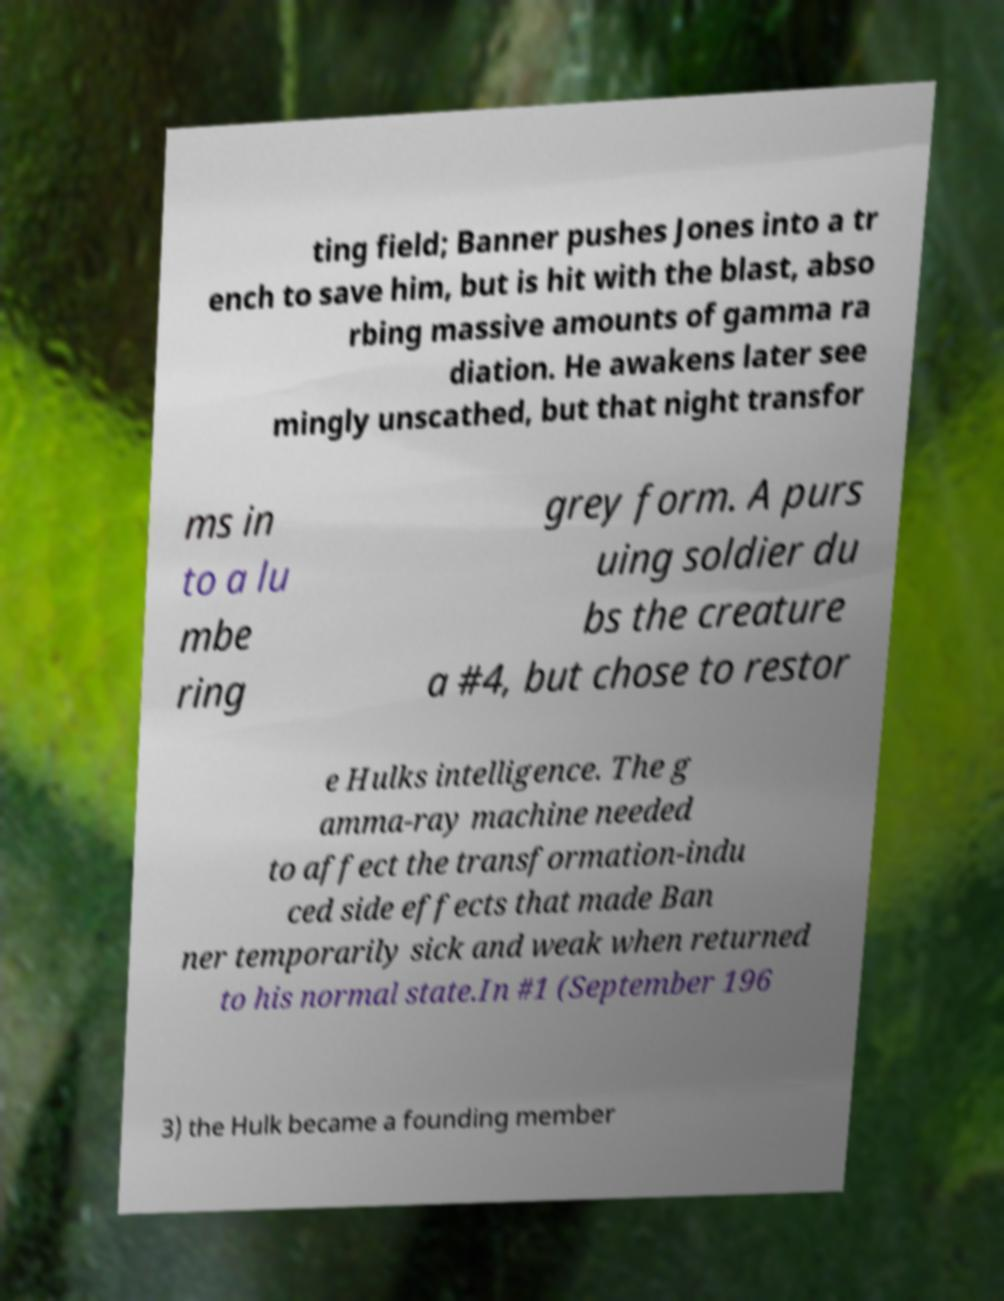Please read and relay the text visible in this image. What does it say? ting field; Banner pushes Jones into a tr ench to save him, but is hit with the blast, abso rbing massive amounts of gamma ra diation. He awakens later see mingly unscathed, but that night transfor ms in to a lu mbe ring grey form. A purs uing soldier du bs the creature a #4, but chose to restor e Hulks intelligence. The g amma-ray machine needed to affect the transformation-indu ced side effects that made Ban ner temporarily sick and weak when returned to his normal state.In #1 (September 196 3) the Hulk became a founding member 